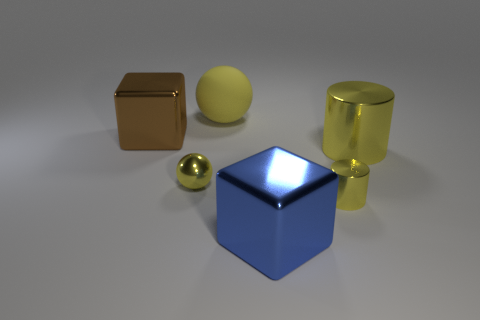What is the material of the big blue thing?
Offer a very short reply. Metal. What number of other cubes are the same size as the brown block?
Make the answer very short. 1. There is a big metallic object that is the same color as the tiny ball; what is its shape?
Your answer should be compact. Cylinder. Are there any brown metallic objects that have the same shape as the matte thing?
Ensure brevity in your answer.  No. There is a cylinder that is the same size as the matte object; what color is it?
Ensure brevity in your answer.  Yellow. There is a block that is in front of the metallic cube that is behind the blue cube; what is its color?
Give a very brief answer. Blue. Do the block that is behind the large yellow metallic cylinder and the tiny sphere have the same color?
Offer a very short reply. No. There is a tiny yellow shiny thing right of the yellow sphere that is to the left of the yellow ball behind the large brown block; what is its shape?
Your answer should be very brief. Cylinder. How many large blue things are behind the cube on the left side of the large yellow ball?
Provide a short and direct response. 0. Do the tiny sphere and the large yellow sphere have the same material?
Ensure brevity in your answer.  No. 